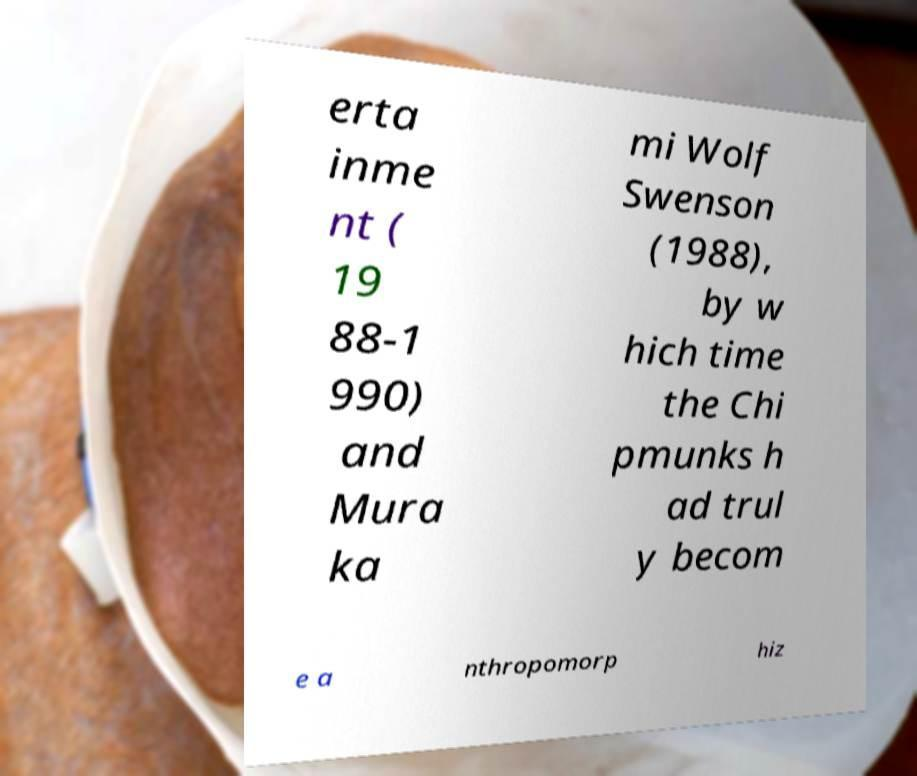For documentation purposes, I need the text within this image transcribed. Could you provide that? erta inme nt ( 19 88-1 990) and Mura ka mi Wolf Swenson (1988), by w hich time the Chi pmunks h ad trul y becom e a nthropomorp hiz 